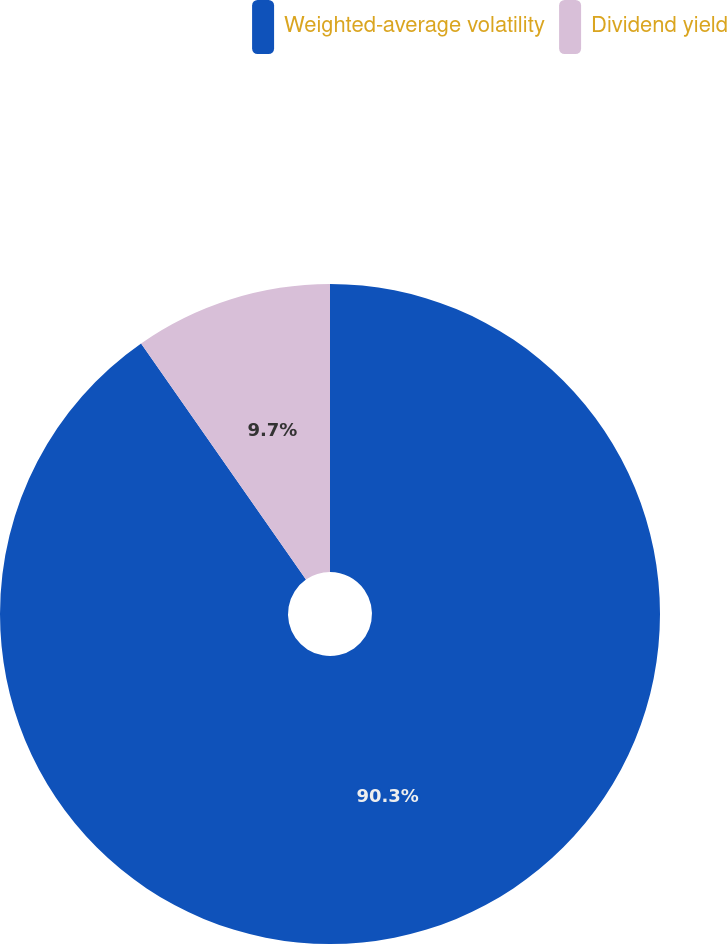<chart> <loc_0><loc_0><loc_500><loc_500><pie_chart><fcel>Weighted-average volatility<fcel>Dividend yield<nl><fcel>90.3%<fcel>9.7%<nl></chart> 